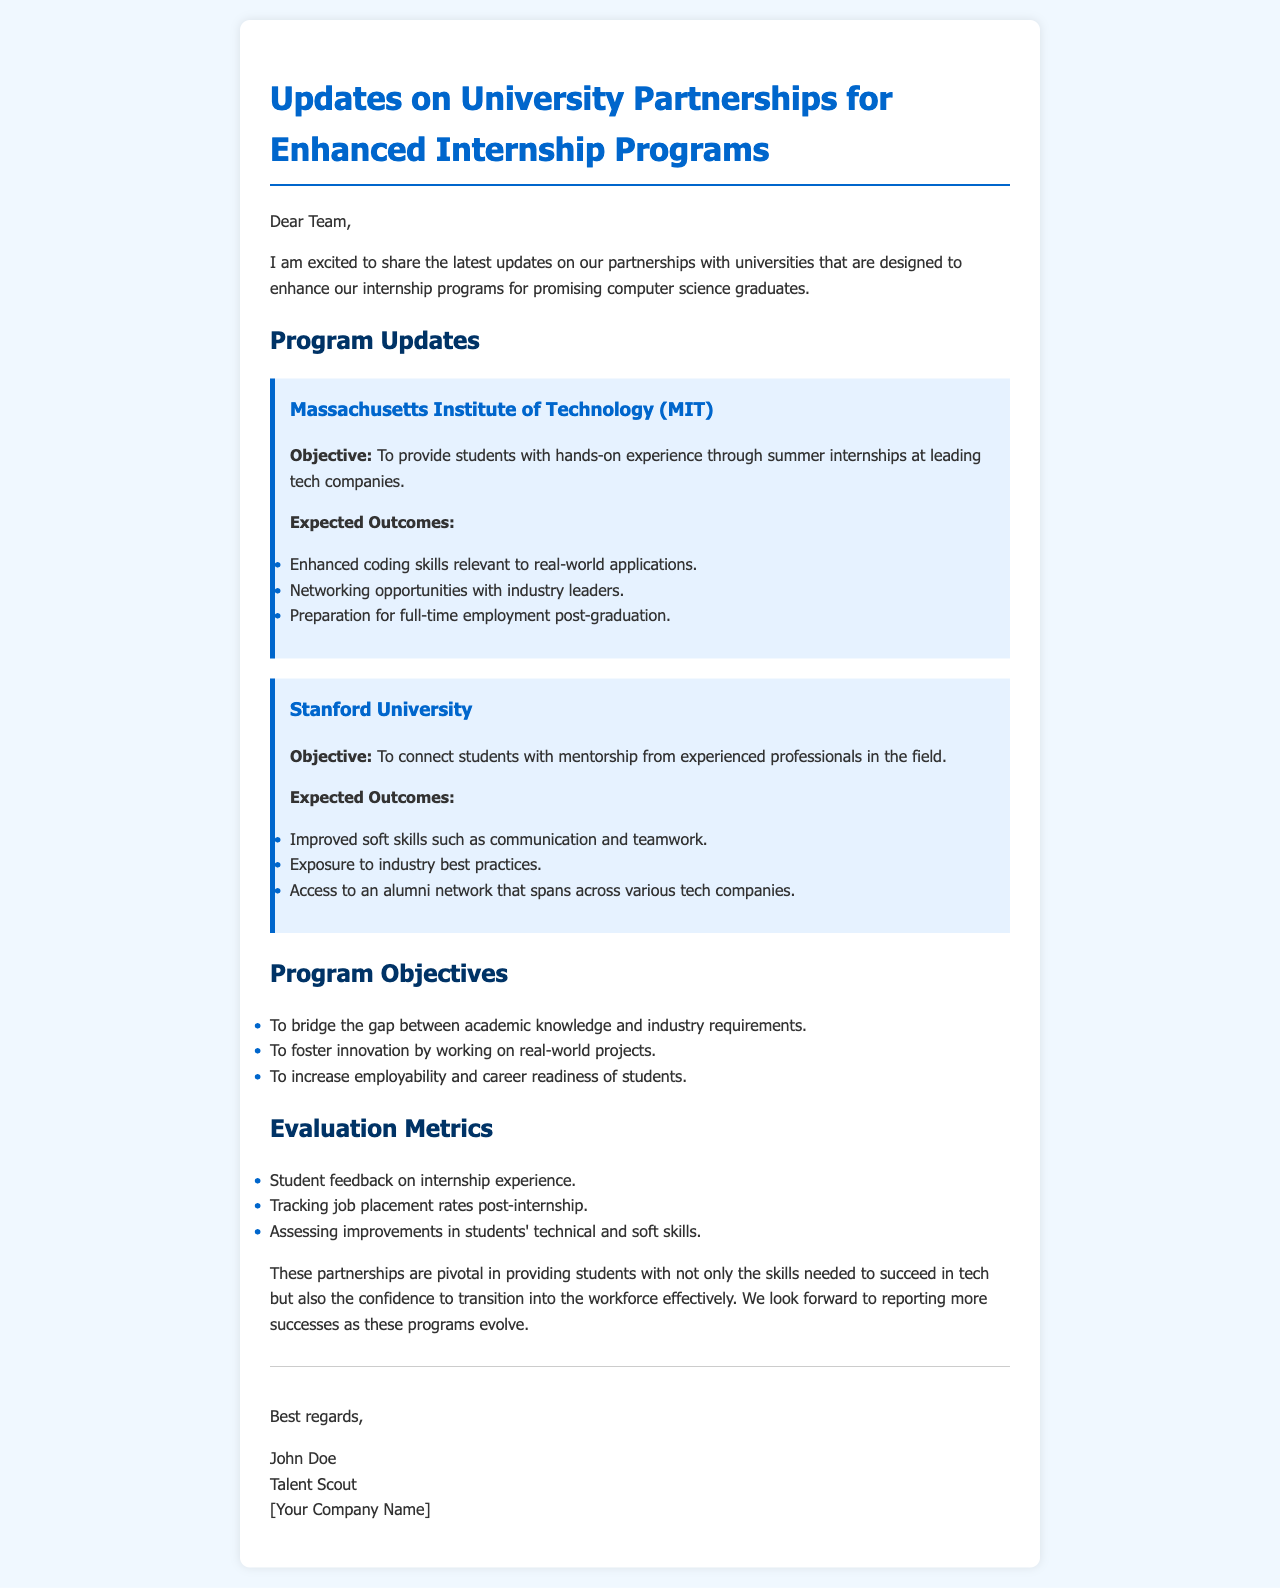What is the title of the document? The title of the document is indicated as the main heading of the content.
Answer: Updates on University Partnerships for Enhanced Internship Programs Who is the author of the document? The author is introduced at the end of the document in the signature section.
Answer: John Doe What is the main objective of the partnership with MIT? The objective is summarized in a section specific to the university.
Answer: To provide students with hands-on experience through summer internships at leading tech companies What expected outcome is related to networking? The expected outcome lists various benefits for students from the internship programs.
Answer: Networking opportunities with industry leaders What skill improvement is highlighted for Stanford University students? The skills are mentioned as expected outcomes of the mentorship provided in the partnership.
Answer: Improved soft skills such as communication and teamwork How many evaluation metrics are mentioned in the document? The evaluation metrics are listed in a section discussing how success will be assessed.
Answer: Three What is one of the program objectives mentioned? The objectives are outlined in a list format, detailing the goals of the internship programs.
Answer: To bridge the gap between academic knowledge and industry requirements What is the background color of the document? The background color can be inferred from the styling defined in the document code.
Answer: Light blue (f0f8ff) 